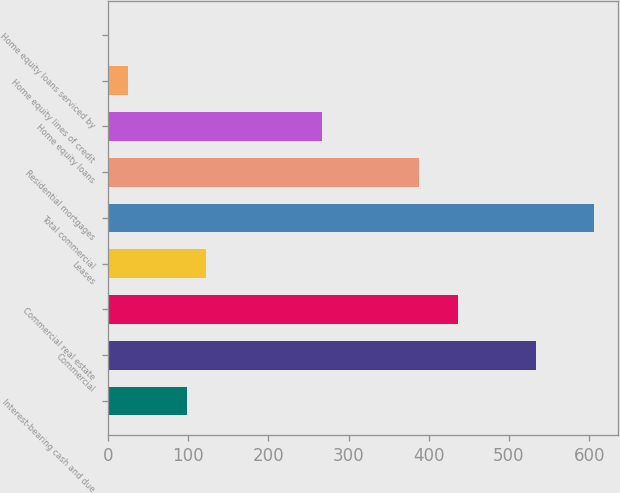<chart> <loc_0><loc_0><loc_500><loc_500><bar_chart><fcel>Interest-bearing cash and due<fcel>Commercial<fcel>Commercial real estate<fcel>Leases<fcel>Total commercial<fcel>Residential mortgages<fcel>Home equity loans<fcel>Home equity lines of credit<fcel>Home equity loans serviced by<nl><fcel>97.8<fcel>533.4<fcel>436.6<fcel>122<fcel>606<fcel>388.2<fcel>267.2<fcel>25.2<fcel>1<nl></chart> 